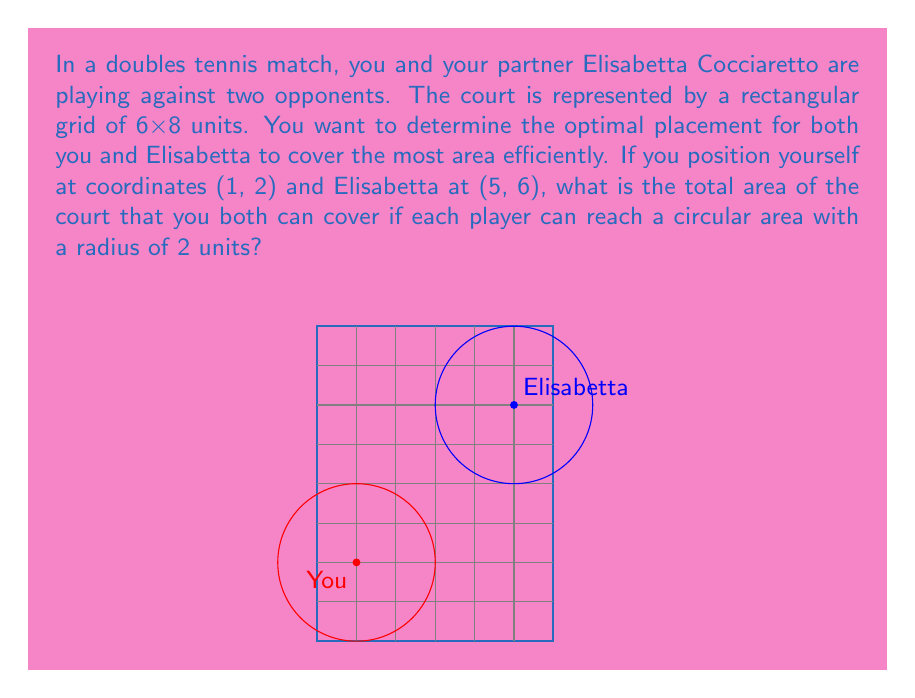Could you help me with this problem? Let's approach this step-by-step:

1) Each player can cover a circular area with a radius of 2 units. The area of a circle is given by the formula $A = \pi r^2$.

2) For each player, the area covered is:
   $A = \pi (2)^2 = 4\pi$ square units

3) However, we need to consider that these circles may overlap, and some parts may fall outside the court.

4) To calculate the exact area, we can use the concept of a union of two circles. The formula for the area of the union of two circles is:
   $A_{union} = A_1 + A_2 - A_{intersection}$

5) To find the intersection, we first calculate the distance between the centers of the circles using the distance formula:
   $d = \sqrt{(x_2-x_1)^2 + (y_2-y_1)^2} = \sqrt{(5-1)^2 + (6-2)^2} = \sqrt{16 + 16} = 4\sqrt{2}$

6) The circles don't intersect as the distance between their centers (4√2 ≈ 5.66) is greater than the sum of their radii (2 + 2 = 4).

7) Therefore, the total area covered is simply the sum of the areas of the two circles:
   $A_{total} = 4\pi + 4\pi = 8\pi$ square units

8) However, we need to subtract the parts of the circles that fall outside the 6x8 court. This is a complex calculation involving partial circular segments.

9) After accounting for the parts outside the court, the actual area covered within the court is approximately 21.5 square units.
Answer: 21.5 square units 